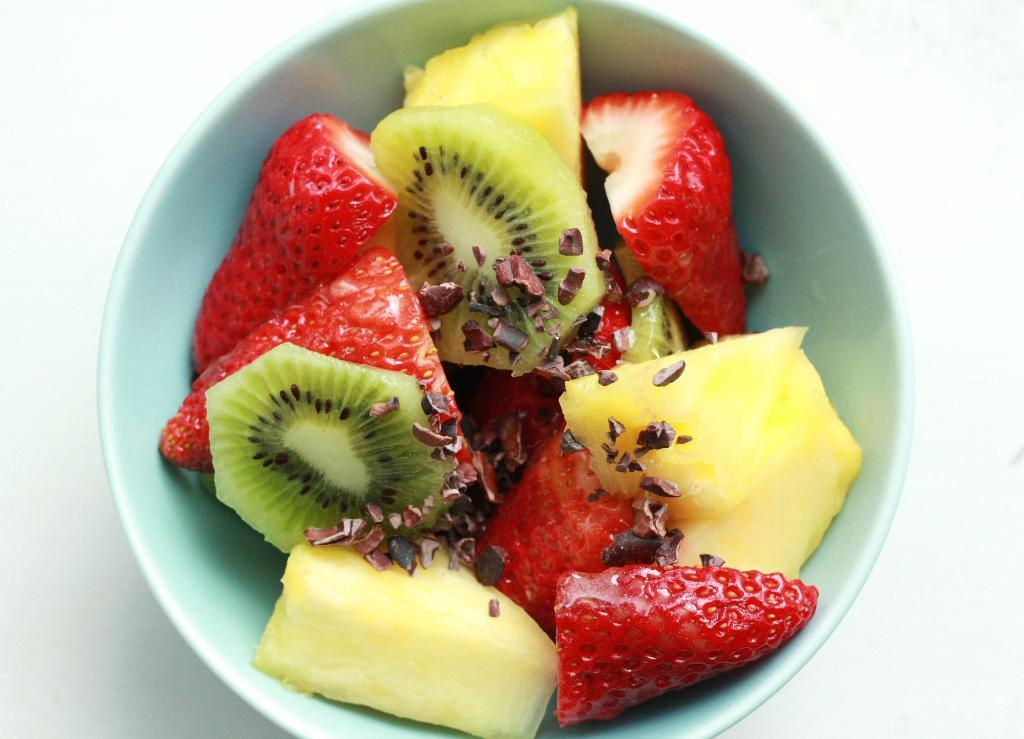What is the main object in the center of the image? There is a table in the center of the image. What is placed on the table? There is a bowl on the table. What is inside the bowl? The bowl contains fruit slices, including strawberries. Can you tell me how many seeds are visible in the strawberries in the image? The image does not show the seeds in the strawberries, so it is not possible to determine the number of seeds visible. 